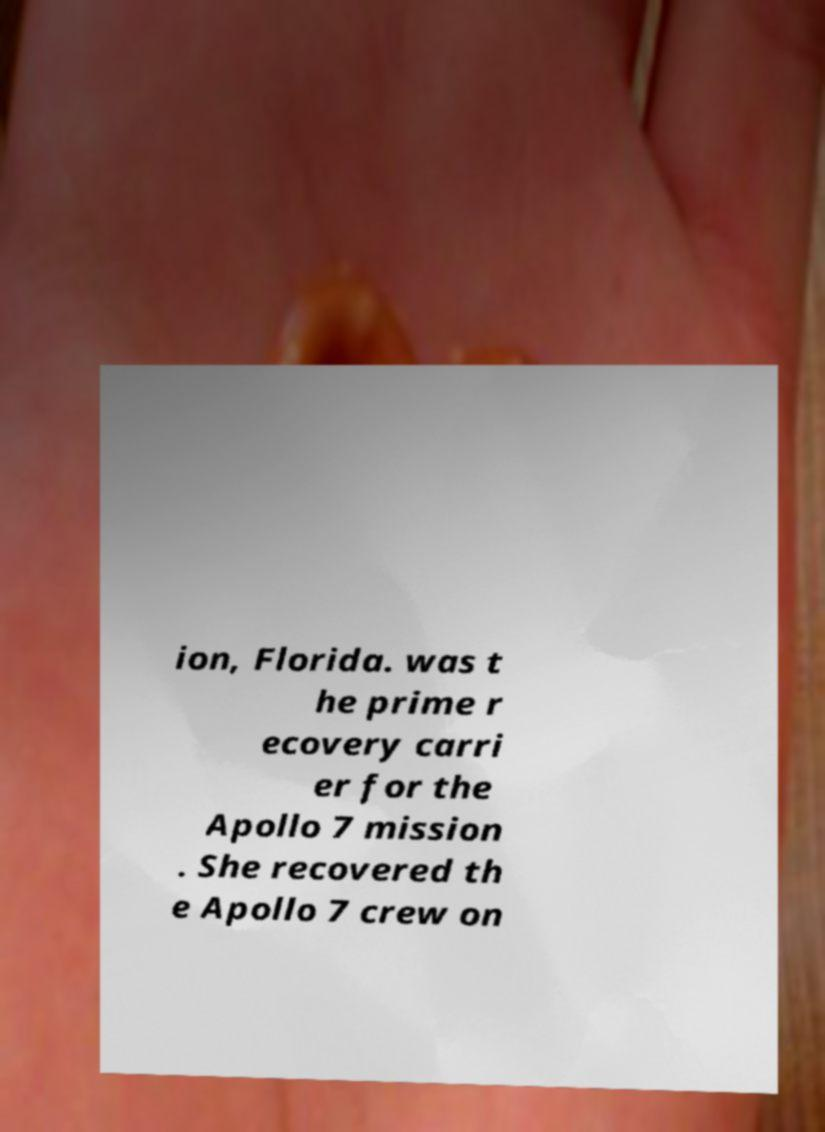There's text embedded in this image that I need extracted. Can you transcribe it verbatim? ion, Florida. was t he prime r ecovery carri er for the Apollo 7 mission . She recovered th e Apollo 7 crew on 